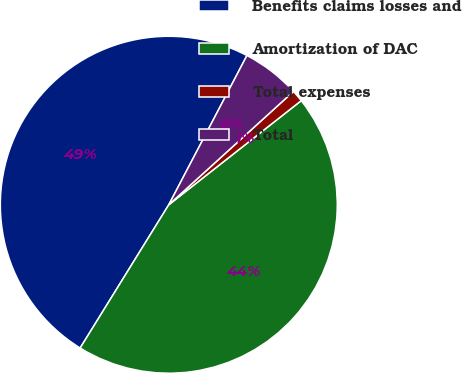Convert chart. <chart><loc_0><loc_0><loc_500><loc_500><pie_chart><fcel>Benefits claims losses and<fcel>Amortization of DAC<fcel>Total expenses<fcel>Total<nl><fcel>48.86%<fcel>44.42%<fcel>1.14%<fcel>5.58%<nl></chart> 